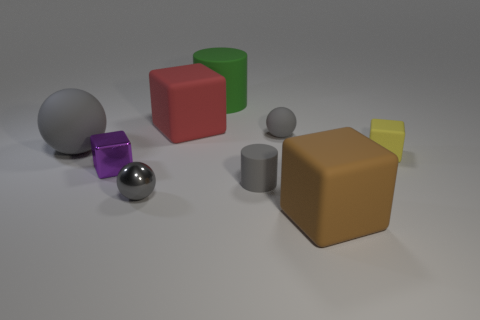Can you describe the arrangement of the shapes in relation to the large brown block? Certainly! The large brown block is centrally located with respect to the other shapes. To its left, a small yellow cube rests against it, and a large green cube is slightly behind. On its right side, there are various geometric shapes at different distances. The closest is a small gray cylinder, followed by a small purple cube, and further back, a large gray sphere. In front, there is a small reflective silver sphere. 